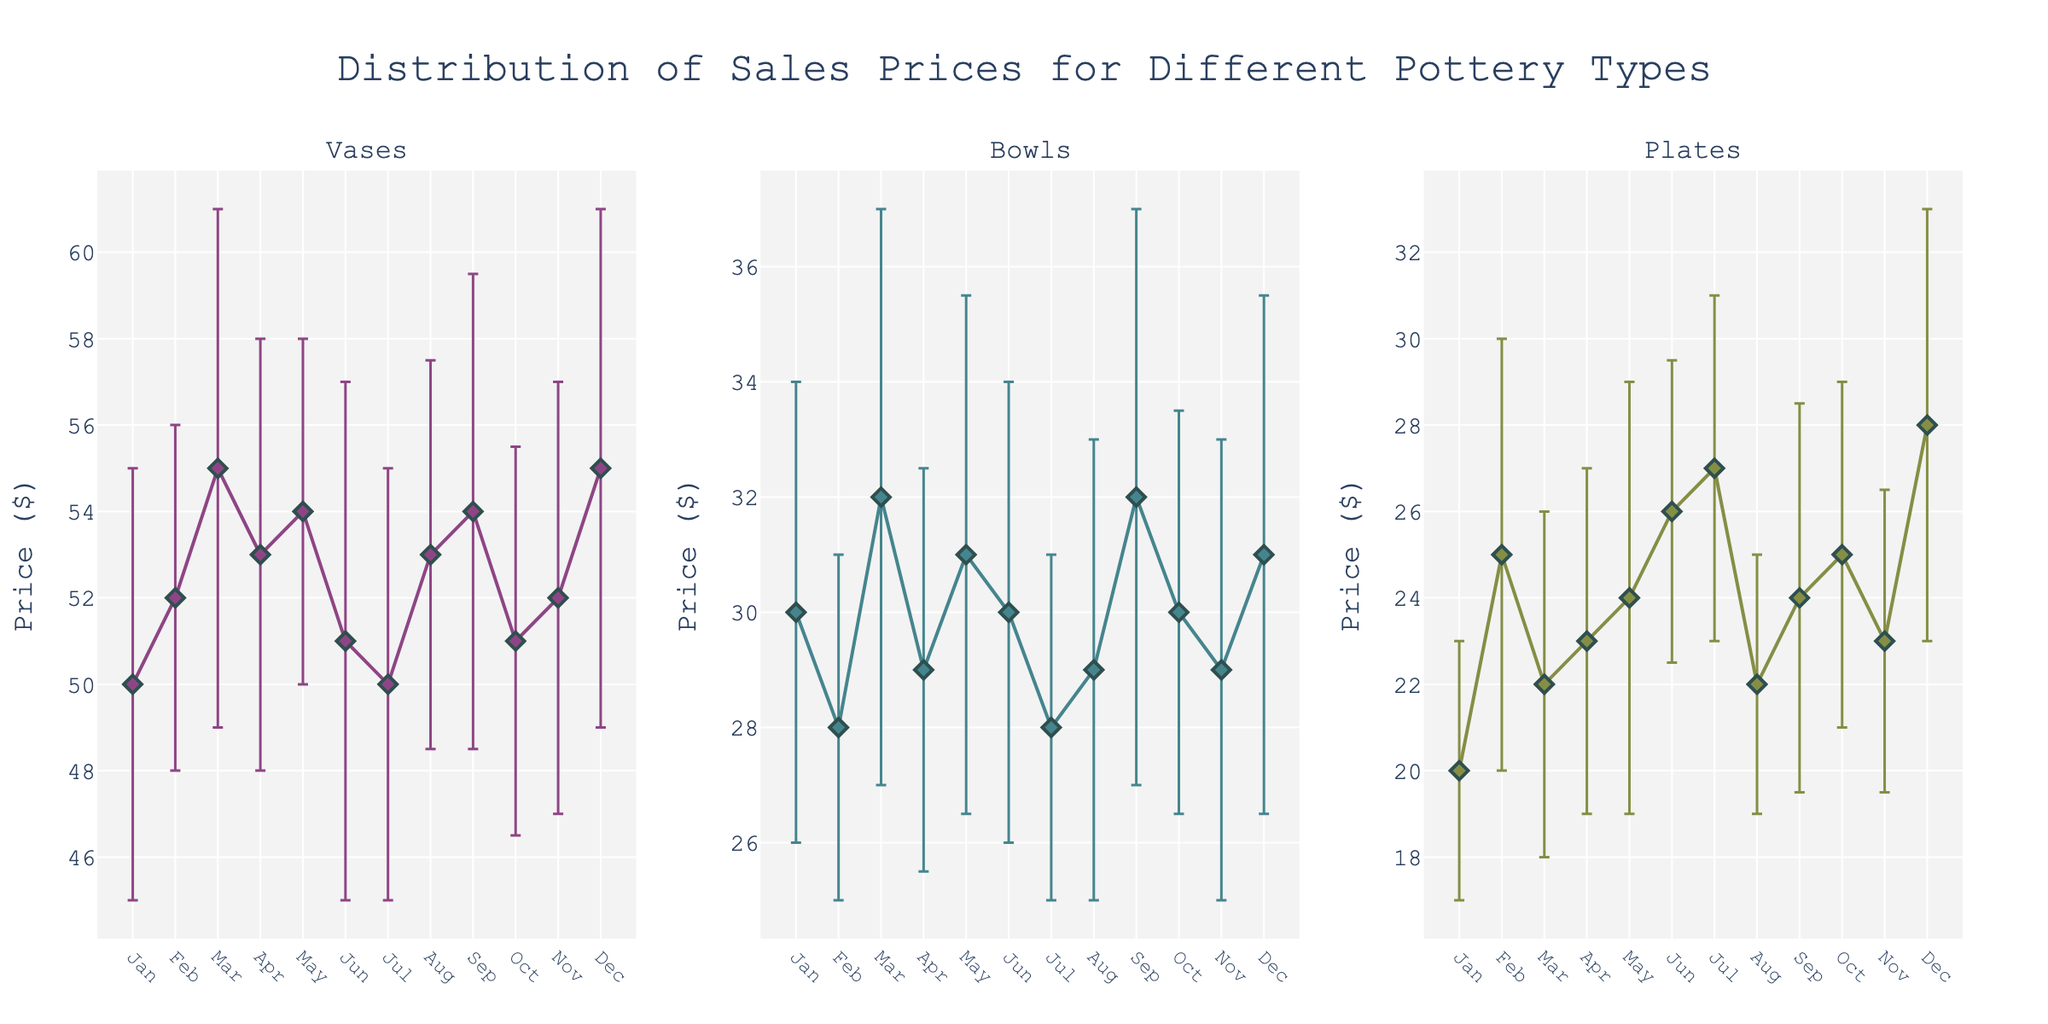How does the price of vases change over the months? Vases have relatively consistent prices, with minor fluctuations between $50 and $55. The highest price occurs in March and December at $55, while the lowest are $50 in January and July.
Answer: Prices fluctuate between $50 and $55 Which type of pottery shows the greatest variability in prices over the months? By observing the error bars, plates exhibit the widest range of variabilities in prices, especially in February and December.
Answer: Plates What is the average price of bowls in the first quarter (January to March)? The prices for bowls in Q1 are $30, $28, and $32. Averaging these values: (30 + 28 + 32) / 3 = 30.
Answer: $30 Which month shows the highest price for plates? December has the highest price for plates, reaching $28.
Answer: December Between bowls and plates, which shows less variability in March? Both bowls and plates have error bars, but bowls with a standard deviation of 5 have a slightly higher variability compared to plates with a standard deviation of 4.
Answer: Plates Which month shows the lowest variance for vases prices? February has the smallest error bar for vases, indicating a standard deviation of 4, the lowest among the months.
Answer: February How do the prices of bowls in July compare with the prices in August? Bowls are priced at $28 in July and $29 in August. July has a slightly lower price.
Answer: July is lower What is the overall trend for vase prices from January to December? Vases show a generally stable pattern with slight increases and decreases, peaking in March and December.
Answer: Relatively stable with minor peaks Compare the prices and variability for plates in February versus March. In February, plates cost $25 with a higher variability (standard deviation of 5), and in March, they are $22 with lower variability (standard deviation of 4).
Answer: February has higher price and variability Are there any months where the prices of all pottery types show significant decreases? July shows decreased prices across all pottery types, with the lowest prices for vases and bowls at $50 and $28 respectively.
Answer: July 